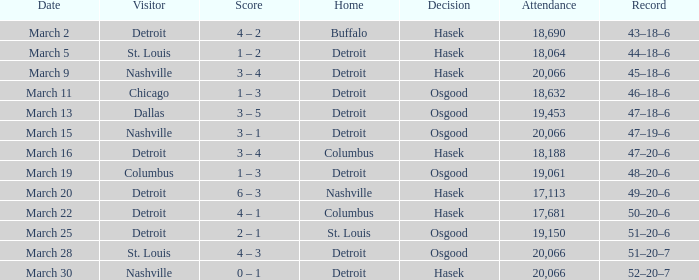What was the decision of the Red Wings game when they had a record of 45–18–6? Hasek. 